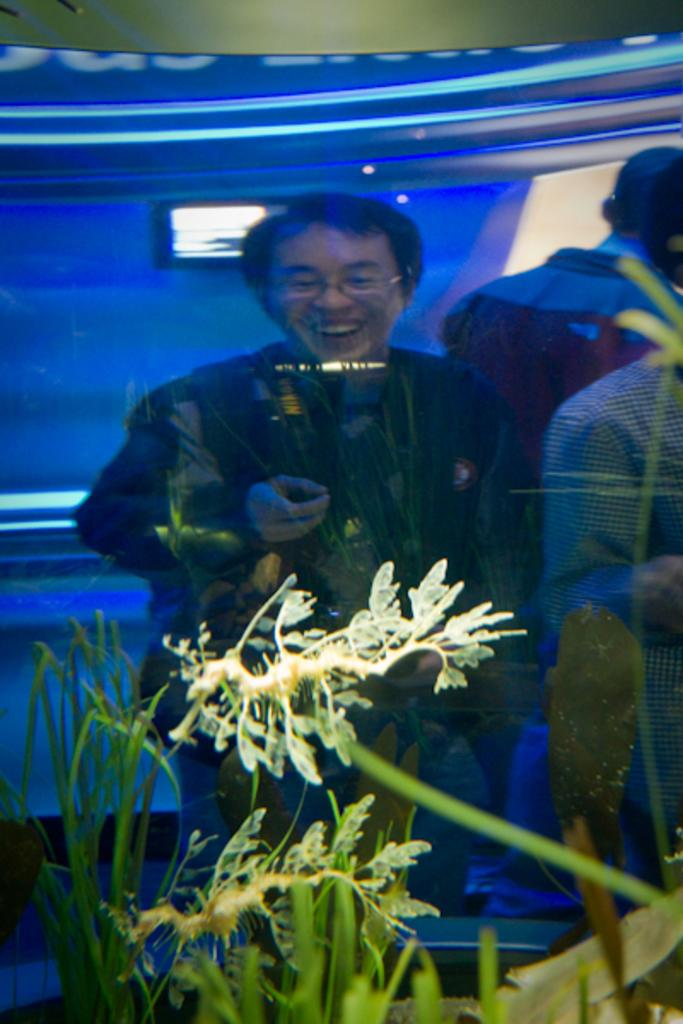What can be seen in the image? There are people and objects in the image. Can you describe the people in the image? The provided facts do not give specific details about the people, so we cannot describe them further. What types of objects are present in the image? The provided facts do not give specific details about the objects, so we cannot describe them further. What color is the tin basketball that the people are crushing in the image? There is no tin basketball present in the image, nor is there any mention of people crushing anything. 